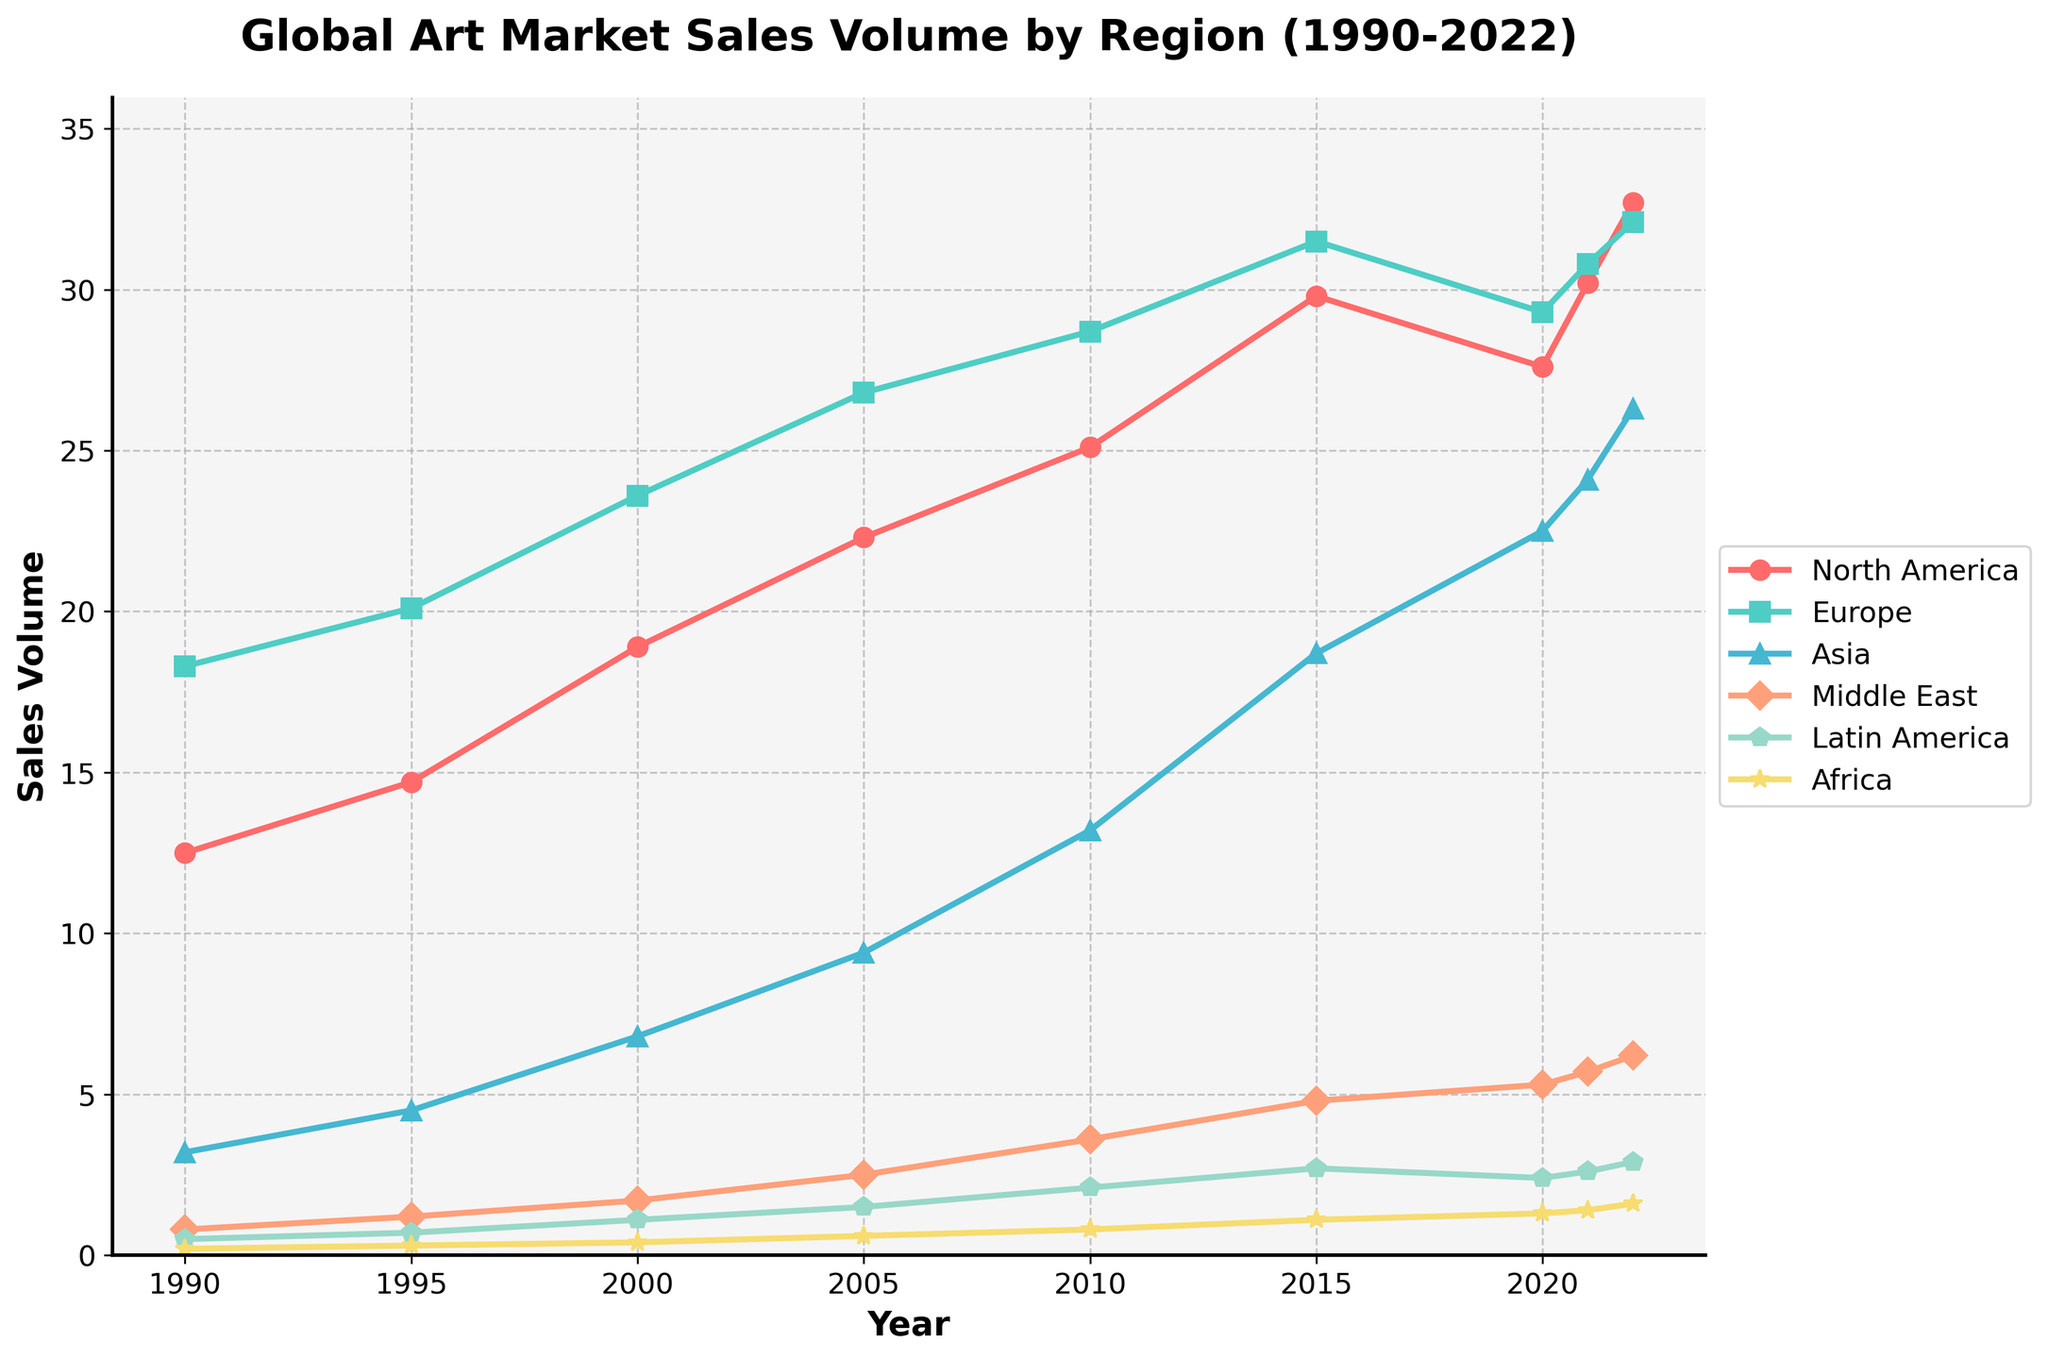Which region had the highest sales volume in 2022? Looking at the data for 2022, North America has the highest sales volume among all regions.
Answer: North America How much did the sales volume in Europe increase from 1990 to 2022? In 1990, Europe had a sales volume of 18.3. By 2022, this increased to 32.1. The difference is 32.1 - 18.3.
Answer: 13.8 Which region experienced the largest growth in sales volume from 1990 to 2022? Analyzing the data for growth, Asia's sales volume increased from 3.2 in 1990 to 26.3 in 2022. This calculates to an increase of 23.1, the largest among the regions.
Answer: Asia Did sales volumes in any regions decrease between any two consecutive periods? Reviewing the yearly sales volume data, only North America experienced a decrease between 2015 (29.8) and 2020 (27.6).
Answer: Yes How did the sales volume for the Middle East change from 2005 to 2015? The Middle East had a sales volume of 2.5 in 2005, which increased to 4.8 by 2015. The change is 4.8 - 2.5.
Answer: 2.3 Which regions showed a consistent upward trend from 1990 to 2022? By examining the sales data, all regions demonstrated a consistent upward trend, but some temporary dips were present.
Answer: All regions What is the average sales volume in Africa across all the given years? Adding the sales volumes for Africa from 1990 to 2022: 0.2 + 0.3 + 0.4 + 0.6 + 0.8 + 1.1 + 1.3 + 1.4 + 1.6 = 7.7. Dividing this sum by the number of years (9), the average is 7.7 / 9.
Answer: 0.856 Compare the sales volume growth between North America and Europe from 1990 to 2022. Which grew more? North America's sales volume grew from 12.5 to 32.7 (increase: 20.2), compared to Europe, which grew from 18.3 to 32.1 (increase: 13.8). Therefore, North America grew more.
Answer: North America What is the combined sales volume for Asia and Latin America in 2010? In 2010, Asia had 13.2 and Latin America had 2.1. Summing these values gives 13.2 + 2.1.
Answer: 15.3 Which regions showed a decline in sales volume between 2015 and 2020? Checking the data for 2015 to 2020, North America's sales volume decreased from 29.8 to 27.6, and Latin America's decreased from 2.7 to 2.4.
Answer: North America and Latin America 